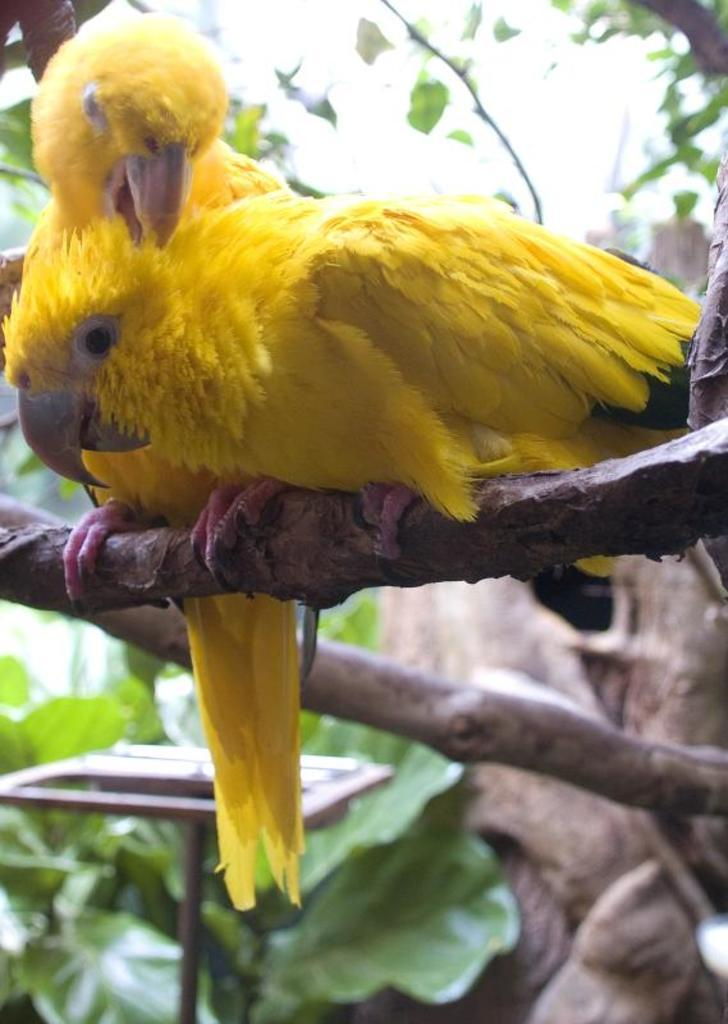How many parrots are in the image? There are two parrots in the image. Where are the parrots located? The parrots are on the branch of a tree. What can be seen in the background of the image? There are leafs and a metal stand in the background of the image. What type of advertisement can be seen in the image? There is no advertisement present in the image; it features two parrots on a tree branch with leafs and a metal stand in the background. 